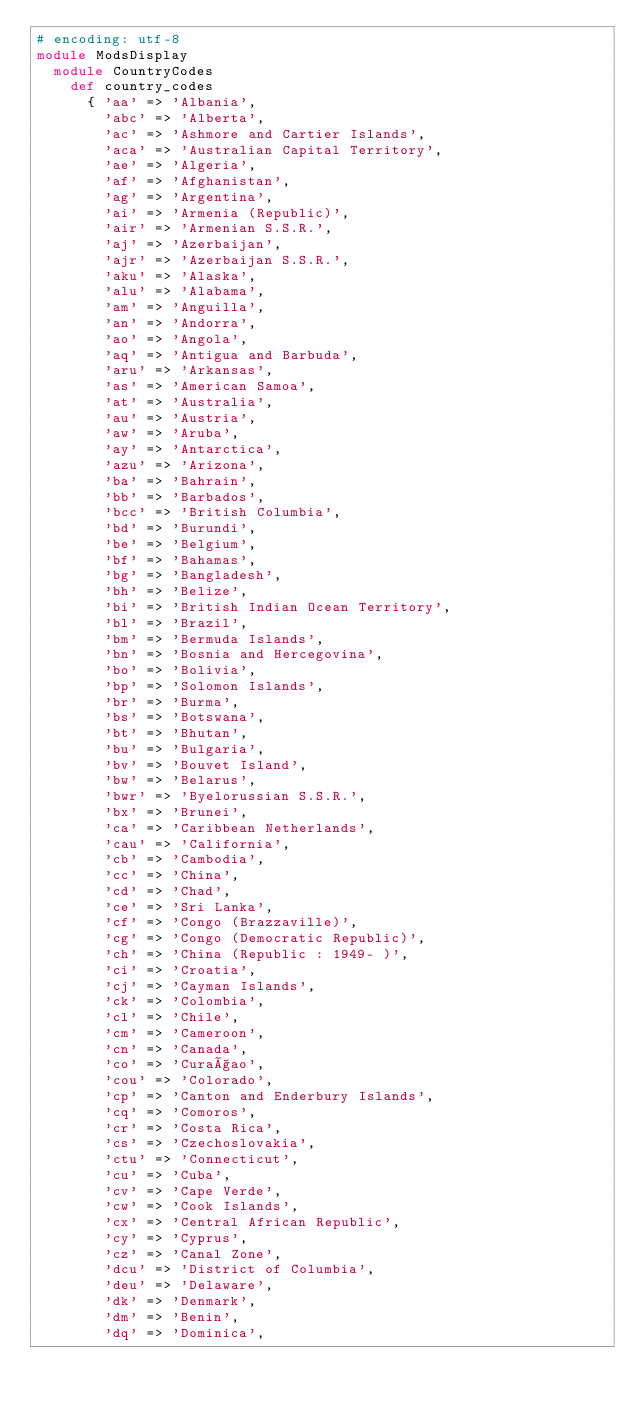<code> <loc_0><loc_0><loc_500><loc_500><_Ruby_># encoding: utf-8
module ModsDisplay
  module CountryCodes
    def country_codes
      { 'aa' => 'Albania',
        'abc' => 'Alberta',
        'ac' => 'Ashmore and Cartier Islands',
        'aca' => 'Australian Capital Territory',
        'ae' => 'Algeria',
        'af' => 'Afghanistan',
        'ag' => 'Argentina',
        'ai' => 'Armenia (Republic)',
        'air' => 'Armenian S.S.R.',
        'aj' => 'Azerbaijan',
        'ajr' => 'Azerbaijan S.S.R.',
        'aku' => 'Alaska',
        'alu' => 'Alabama',
        'am' => 'Anguilla',
        'an' => 'Andorra',
        'ao' => 'Angola',
        'aq' => 'Antigua and Barbuda',
        'aru' => 'Arkansas',
        'as' => 'American Samoa',
        'at' => 'Australia',
        'au' => 'Austria',
        'aw' => 'Aruba',
        'ay' => 'Antarctica',
        'azu' => 'Arizona',
        'ba' => 'Bahrain',
        'bb' => 'Barbados',
        'bcc' => 'British Columbia',
        'bd' => 'Burundi',
        'be' => 'Belgium',
        'bf' => 'Bahamas',
        'bg' => 'Bangladesh',
        'bh' => 'Belize',
        'bi' => 'British Indian Ocean Territory',
        'bl' => 'Brazil',
        'bm' => 'Bermuda Islands',
        'bn' => 'Bosnia and Hercegovina',
        'bo' => 'Bolivia',
        'bp' => 'Solomon Islands',
        'br' => 'Burma',
        'bs' => 'Botswana',
        'bt' => 'Bhutan',
        'bu' => 'Bulgaria',
        'bv' => 'Bouvet Island',
        'bw' => 'Belarus',
        'bwr' => 'Byelorussian S.S.R.',
        'bx' => 'Brunei',
        'ca' => 'Caribbean Netherlands',
        'cau' => 'California',
        'cb' => 'Cambodia',
        'cc' => 'China',
        'cd' => 'Chad',
        'ce' => 'Sri Lanka',
        'cf' => 'Congo (Brazzaville)',
        'cg' => 'Congo (Democratic Republic)',
        'ch' => 'China (Republic : 1949- )',
        'ci' => 'Croatia',
        'cj' => 'Cayman Islands',
        'ck' => 'Colombia',
        'cl' => 'Chile',
        'cm' => 'Cameroon',
        'cn' => 'Canada',
        'co' => 'Curaçao',
        'cou' => 'Colorado',
        'cp' => 'Canton and Enderbury Islands',
        'cq' => 'Comoros',
        'cr' => 'Costa Rica',
        'cs' => 'Czechoslovakia',
        'ctu' => 'Connecticut',
        'cu' => 'Cuba',
        'cv' => 'Cape Verde',
        'cw' => 'Cook Islands',
        'cx' => 'Central African Republic',
        'cy' => 'Cyprus',
        'cz' => 'Canal Zone',
        'dcu' => 'District of Columbia',
        'deu' => 'Delaware',
        'dk' => 'Denmark',
        'dm' => 'Benin',
        'dq' => 'Dominica',</code> 